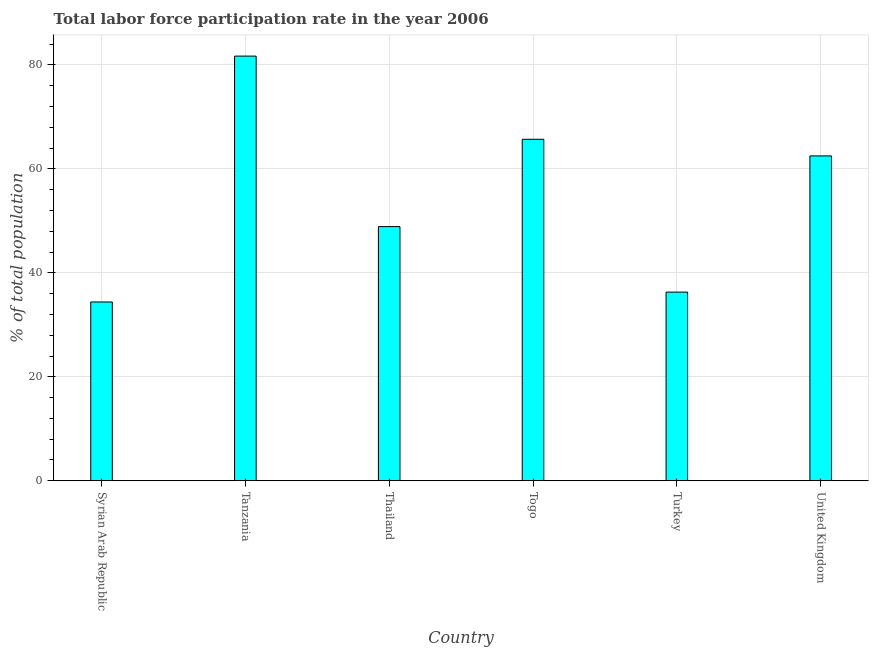Does the graph contain grids?
Your answer should be very brief. Yes. What is the title of the graph?
Offer a terse response. Total labor force participation rate in the year 2006. What is the label or title of the Y-axis?
Your response must be concise. % of total population. What is the total labor force participation rate in Syrian Arab Republic?
Offer a very short reply. 34.4. Across all countries, what is the maximum total labor force participation rate?
Ensure brevity in your answer.  81.7. Across all countries, what is the minimum total labor force participation rate?
Your response must be concise. 34.4. In which country was the total labor force participation rate maximum?
Offer a very short reply. Tanzania. In which country was the total labor force participation rate minimum?
Offer a terse response. Syrian Arab Republic. What is the sum of the total labor force participation rate?
Ensure brevity in your answer.  329.5. What is the difference between the total labor force participation rate in Thailand and Togo?
Your answer should be very brief. -16.8. What is the average total labor force participation rate per country?
Give a very brief answer. 54.92. What is the median total labor force participation rate?
Give a very brief answer. 55.7. In how many countries, is the total labor force participation rate greater than 24 %?
Keep it short and to the point. 6. What is the ratio of the total labor force participation rate in Thailand to that in United Kingdom?
Provide a succinct answer. 0.78. Is the difference between the total labor force participation rate in Turkey and United Kingdom greater than the difference between any two countries?
Offer a very short reply. No. What is the difference between the highest and the second highest total labor force participation rate?
Provide a succinct answer. 16. What is the difference between the highest and the lowest total labor force participation rate?
Ensure brevity in your answer.  47.3. In how many countries, is the total labor force participation rate greater than the average total labor force participation rate taken over all countries?
Your answer should be compact. 3. Are all the bars in the graph horizontal?
Provide a short and direct response. No. What is the % of total population in Syrian Arab Republic?
Your response must be concise. 34.4. What is the % of total population of Tanzania?
Offer a very short reply. 81.7. What is the % of total population of Thailand?
Give a very brief answer. 48.9. What is the % of total population in Togo?
Your response must be concise. 65.7. What is the % of total population in Turkey?
Your response must be concise. 36.3. What is the % of total population of United Kingdom?
Your response must be concise. 62.5. What is the difference between the % of total population in Syrian Arab Republic and Tanzania?
Provide a short and direct response. -47.3. What is the difference between the % of total population in Syrian Arab Republic and Togo?
Provide a short and direct response. -31.3. What is the difference between the % of total population in Syrian Arab Republic and United Kingdom?
Make the answer very short. -28.1. What is the difference between the % of total population in Tanzania and Thailand?
Offer a terse response. 32.8. What is the difference between the % of total population in Tanzania and Togo?
Your answer should be very brief. 16. What is the difference between the % of total population in Tanzania and Turkey?
Offer a very short reply. 45.4. What is the difference between the % of total population in Thailand and Togo?
Your answer should be compact. -16.8. What is the difference between the % of total population in Thailand and Turkey?
Your response must be concise. 12.6. What is the difference between the % of total population in Togo and Turkey?
Give a very brief answer. 29.4. What is the difference between the % of total population in Togo and United Kingdom?
Offer a terse response. 3.2. What is the difference between the % of total population in Turkey and United Kingdom?
Your answer should be compact. -26.2. What is the ratio of the % of total population in Syrian Arab Republic to that in Tanzania?
Make the answer very short. 0.42. What is the ratio of the % of total population in Syrian Arab Republic to that in Thailand?
Ensure brevity in your answer.  0.7. What is the ratio of the % of total population in Syrian Arab Republic to that in Togo?
Provide a succinct answer. 0.52. What is the ratio of the % of total population in Syrian Arab Republic to that in Turkey?
Offer a terse response. 0.95. What is the ratio of the % of total population in Syrian Arab Republic to that in United Kingdom?
Offer a terse response. 0.55. What is the ratio of the % of total population in Tanzania to that in Thailand?
Keep it short and to the point. 1.67. What is the ratio of the % of total population in Tanzania to that in Togo?
Your answer should be very brief. 1.24. What is the ratio of the % of total population in Tanzania to that in Turkey?
Your answer should be very brief. 2.25. What is the ratio of the % of total population in Tanzania to that in United Kingdom?
Provide a succinct answer. 1.31. What is the ratio of the % of total population in Thailand to that in Togo?
Ensure brevity in your answer.  0.74. What is the ratio of the % of total population in Thailand to that in Turkey?
Give a very brief answer. 1.35. What is the ratio of the % of total population in Thailand to that in United Kingdom?
Offer a very short reply. 0.78. What is the ratio of the % of total population in Togo to that in Turkey?
Your answer should be compact. 1.81. What is the ratio of the % of total population in Togo to that in United Kingdom?
Provide a succinct answer. 1.05. What is the ratio of the % of total population in Turkey to that in United Kingdom?
Your answer should be compact. 0.58. 